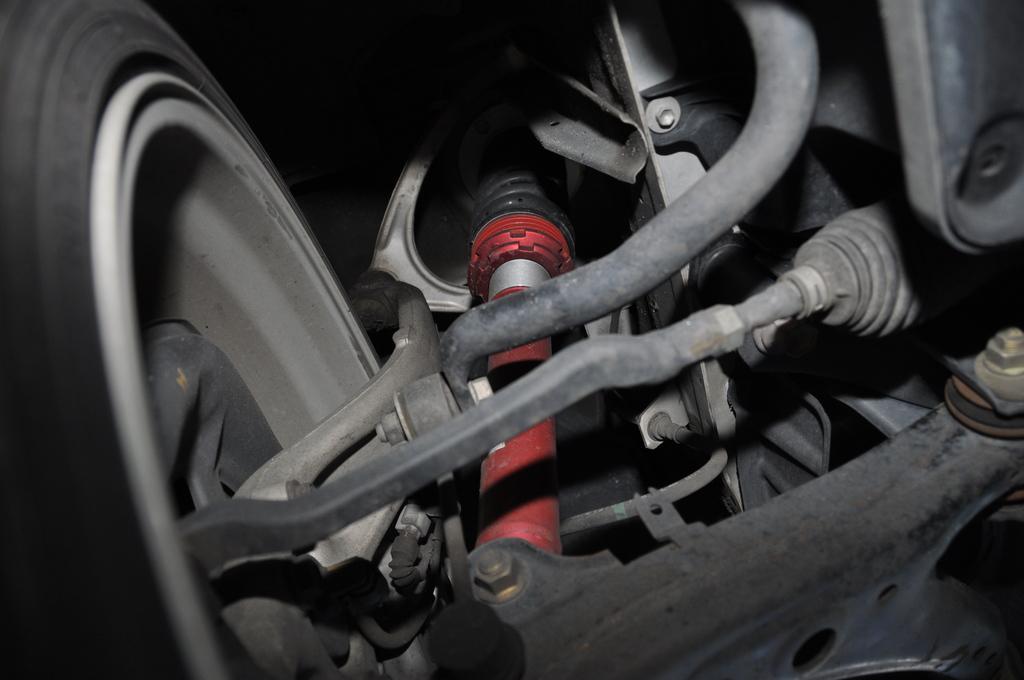Please provide a concise description of this image. In the image there is a car tire on the left side with shock absorbers with a casing on the right side. 